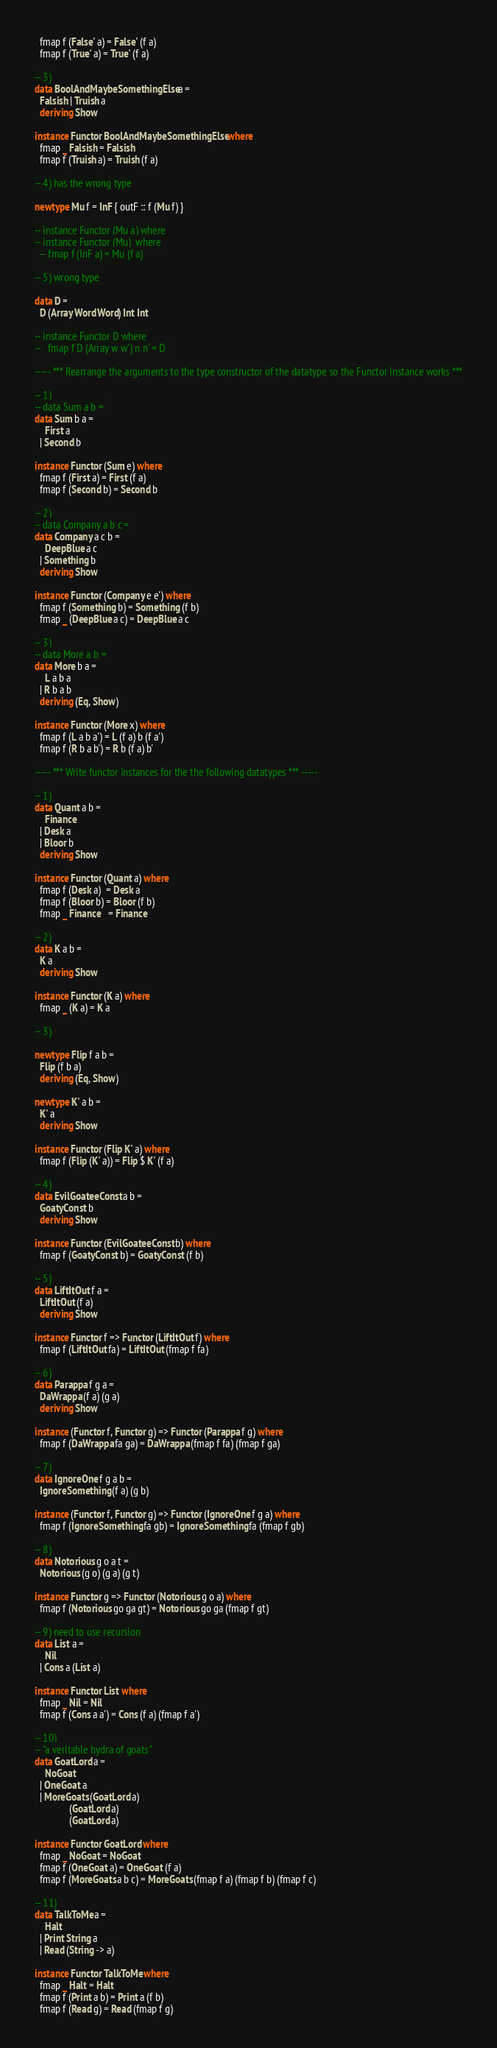Convert code to text. <code><loc_0><loc_0><loc_500><loc_500><_Haskell_>  fmap f (False' a) = False' (f a)
  fmap f (True' a) = True' (f a)

-- 3)
data BoolAndMaybeSomethingElse a =
  Falsish | Truish a
  deriving Show

instance Functor BoolAndMaybeSomethingElse where
  fmap _ Falsish = Falsish
  fmap f (Truish a) = Truish (f a)

-- 4) has the wrong type

newtype Mu f = InF { outF :: f (Mu f) }

-- instance Functor (Mu a) where
-- instance Functor (Mu)  where
  -- fmap f (InF a) = Mu (f a)

-- 5) wrong type

data D =
  D (Array Word Word) Int Int

-- instance Functor D where
--   fmap f D (Array w w') n n' = D 

----- *** Rearrange the arguments to the type constructor of the datatype so the Functor instance works ***

-- 1)
-- data Sum a b =
data Sum b a =
    First a
  | Second b

instance Functor (Sum e) where
  fmap f (First a) = First (f a)
  fmap f (Second b) = Second b

-- 2)
-- data Company a b c =
data Company a c b =
    DeepBlue a c
  | Something b
  deriving Show

instance Functor (Company e e') where
  fmap f (Something b) = Something (f b)
  fmap _ (DeepBlue a c) = DeepBlue a c

-- 3)
-- data More a b =
data More b a =
    L a b a
  | R b a b
  deriving (Eq, Show)

instance Functor (More x) where
  fmap f (L a b a') = L (f a) b (f a')
  fmap f (R b a b') = R b (f a) b'

----- *** Write functor instances for the the following datatypes *** -----

-- 1)
data Quant a b =
    Finance
  | Desk a
  | Bloor b
  deriving Show

instance Functor (Quant a) where
  fmap f (Desk a)  = Desk a 
  fmap f (Bloor b) = Bloor (f b)
  fmap _ Finance   = Finance

-- 2)
data K a b =
  K a
  deriving Show

instance Functor (K a) where
  fmap _ (K a) = K a

-- 3)

newtype Flip f a b =
  Flip (f b a)
  deriving (Eq, Show)

newtype K' a b =
  K' a
  deriving Show

instance Functor (Flip K' a) where
  fmap f (Flip (K' a)) = Flip $ K' (f a)

-- 4)
data EvilGoateeConst a b =
  GoatyConst b
  deriving Show

instance Functor (EvilGoateeConst b) where
  fmap f (GoatyConst b) = GoatyConst (f b)

-- 5)
data LiftItOut f a =
  LiftItOut (f a)
  deriving Show

instance Functor f => Functor (LiftItOut f) where
  fmap f (LiftItOut fa) = LiftItOut (fmap f fa)

-- 6)
data Parappa f g a =
  DaWrappa (f a) (g a)
  deriving Show

instance (Functor f, Functor g) => Functor (Parappa f g) where
  fmap f (DaWrappa fa ga) = DaWrappa (fmap f fa) (fmap f ga)

-- 7)
data IgnoreOne f g a b =
  IgnoreSomething (f a) (g b)

instance (Functor f, Functor g) => Functor (IgnoreOne f g a) where
  fmap f (IgnoreSomething fa gb) = IgnoreSomething fa (fmap f gb)

-- 8)
data Notorious g o a t =
  Notorious (g o) (g a) (g t)

instance Functor g => Functor (Notorious g o a) where
  fmap f (Notorious go ga gt) = Notorious go ga (fmap f gt)

-- 9) need to use recursion
data List a =
    Nil
  | Cons a (List a)

instance Functor List where
  fmap _ Nil = Nil
  fmap f (Cons a a') = Cons (f a) (fmap f a')

-- 10)
-- "a veritable hydra of goats"
data GoatLord a =
    NoGoat
  | OneGoat a
  | MoreGoats (GoatLord a)
              (GoatLord a)
              (GoatLord a)

instance Functor GoatLord where
  fmap _ NoGoat = NoGoat
  fmap f (OneGoat a) = OneGoat (f a)
  fmap f (MoreGoats a b c) = MoreGoats (fmap f a) (fmap f b) (fmap f c)

-- 11)
data TalkToMe a =
    Halt
  | Print String a
  | Read (String -> a)

instance Functor TalkToMe where
  fmap _ Halt = Halt
  fmap f (Print a b) = Print a (f b)
  fmap f (Read g) = Read (fmap f g)
</code> 